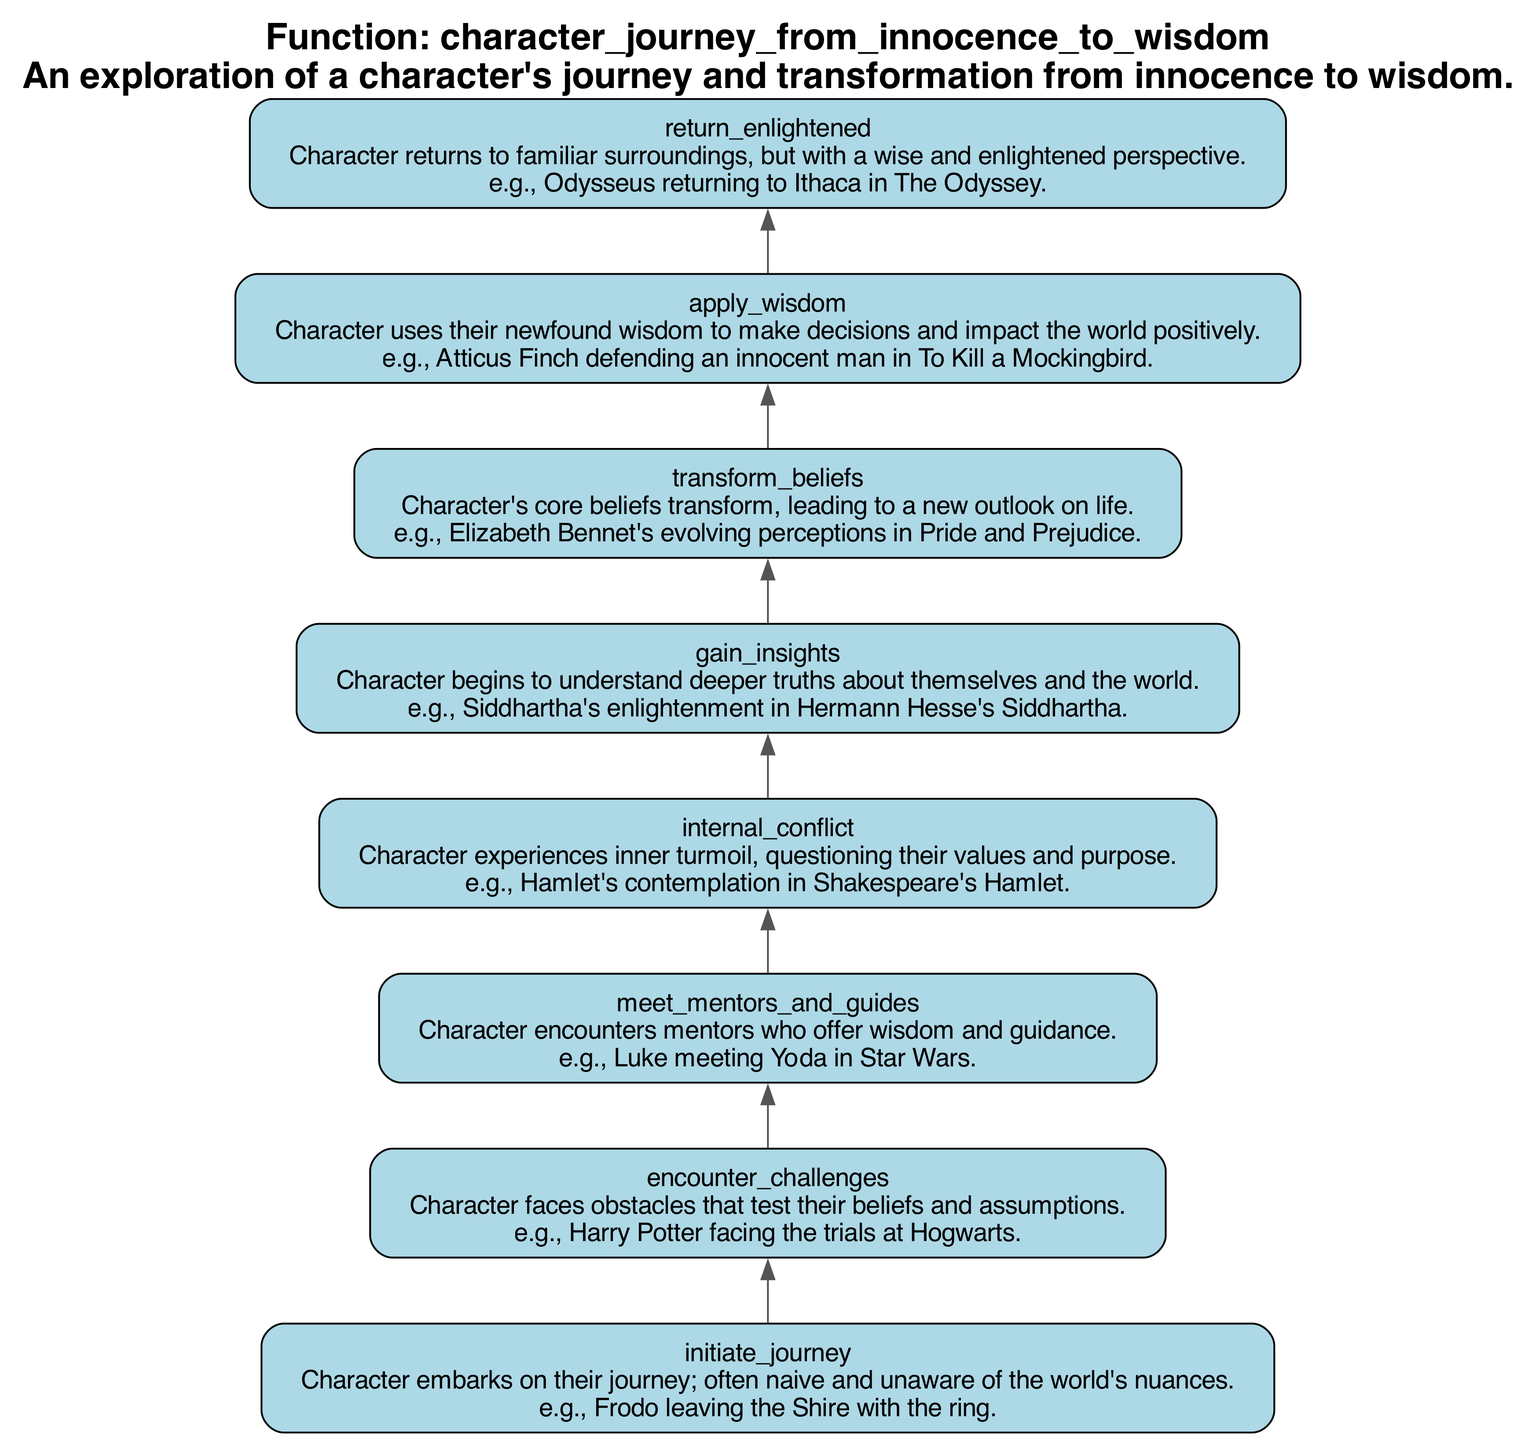What is the first step of the character's journey? The first step, as seen at the bottom of the flowchart, is "initiate_journey." This indicates the character begins their journey, typically being naive and unaware.
Answer: initiate journey How many elements are in the character's journey? Counting the nodes listed in the flowchart reveals that there are eight distinct elements representing the steps in the character's journey.
Answer: eight What does the node "gain_insights" signify? The node "gain_insights" signifies that the character begins to understand deeper truths about themselves and the world. This is a critical step in their transformation.
Answer: Character begins to understand deeper truths about themselves and the world Which node follows "encounter_challenges"? Based on the flow direction from bottom to top, the node that follows "encounter_challenges" is "meet_mentors_and_guides." This shows the character receives guidance after facing challenges.
Answer: meet mentors and guides What transformation occurs after "internal_conflict"? After "internal_conflict," the character undergoes a transformation in their beliefs, represented by the node "transform_beliefs." This indicates a pivotal change in their outlook following their inner struggles.
Answer: transform beliefs How does a character apply their newfound wisdom? The character applies their newfound wisdom in the "apply_wisdom" step, where they use the insights gained to make decisions that positively impact the world.
Answer: uses their newfound wisdom to make decisions positively What is the significance of the "return_enlightened" step? The "return_enlightened" step signifies that the character returns to familiar surroundings, but with a wiser and enlightened perspective, indicating their growth through the journey.
Answer: character returns to familiar surroundings, but wiser Which two nodes are directly connected to "meet_mentors_and_guides"? "meet_mentors_and_guides" is directly connected to "encounter_challenges" as its predecessor and "internal_conflict" as its successor, showing the flow from learning guidance to facing inner struggles.
Answer: encounter challenges and internal conflict 